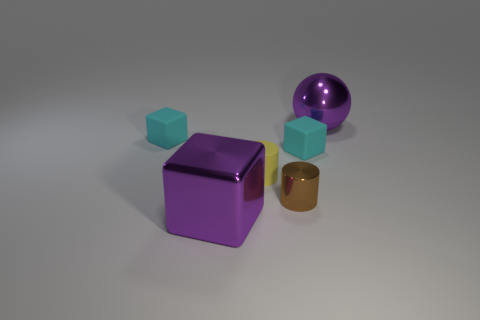Is the number of metal objects that are behind the tiny matte cylinder greater than the number of tiny blue matte cylinders?
Your answer should be compact. Yes. What number of brown metal cylinders are the same size as the purple metallic cube?
Ensure brevity in your answer.  0. How many large objects are either brown cubes or brown cylinders?
Ensure brevity in your answer.  0. How many cyan matte objects are there?
Your answer should be very brief. 2. Are there the same number of tiny rubber blocks that are on the left side of the yellow object and small rubber objects behind the metallic sphere?
Your response must be concise. No. There is a yellow thing; are there any shiny cubes right of it?
Offer a very short reply. No. There is a big thing that is to the left of the brown shiny object; what is its color?
Ensure brevity in your answer.  Purple. What material is the small object behind the tiny cyan rubber block that is to the right of the metallic block?
Make the answer very short. Rubber. Are there fewer cubes that are on the left side of the large shiny block than brown cylinders that are on the right side of the purple ball?
Your answer should be compact. No. How many cyan objects are tiny matte blocks or big rubber objects?
Ensure brevity in your answer.  2. 